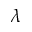Convert formula to latex. <formula><loc_0><loc_0><loc_500><loc_500>\lambda</formula> 